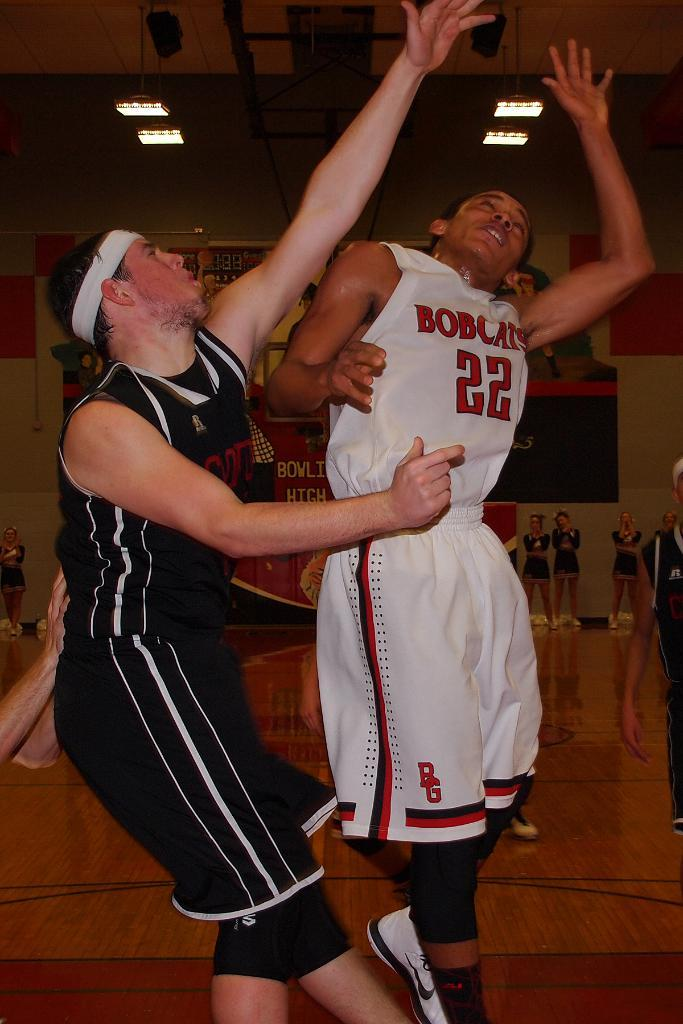<image>
Provide a brief description of the given image. a person with the number 22 on their outfit 